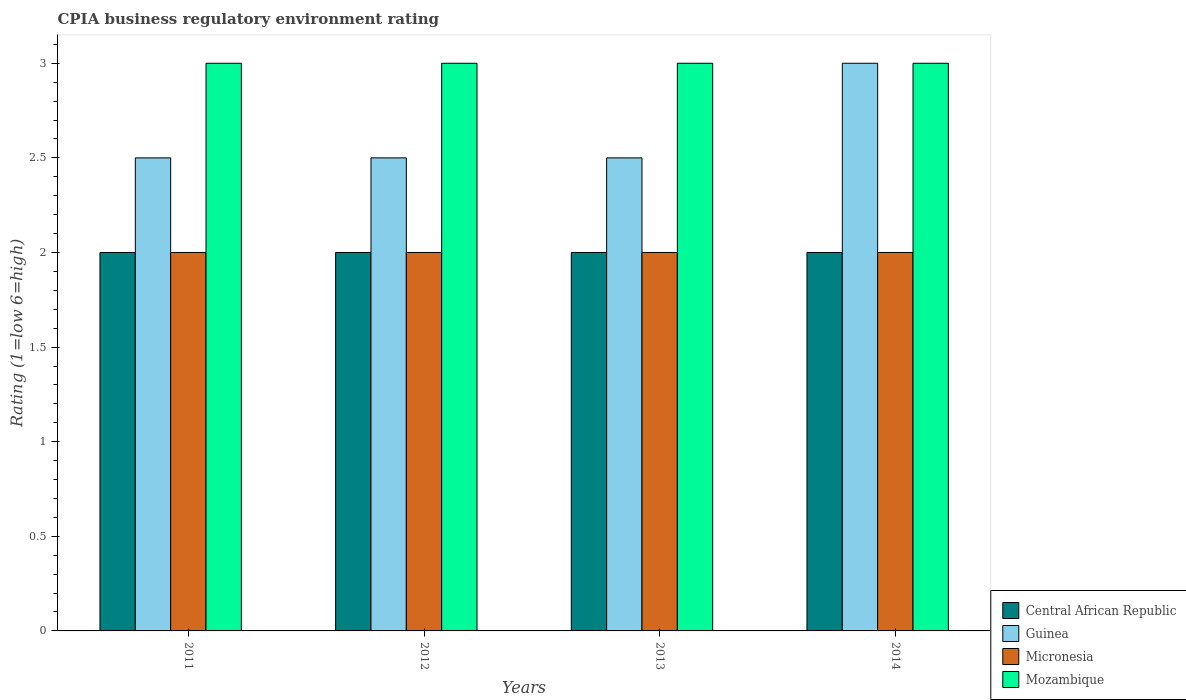How many different coloured bars are there?
Offer a terse response. 4. Are the number of bars on each tick of the X-axis equal?
Provide a short and direct response. Yes. In how many cases, is the number of bars for a given year not equal to the number of legend labels?
Your answer should be very brief. 0. What is the CPIA rating in Guinea in 2011?
Your answer should be compact. 2.5. Across all years, what is the maximum CPIA rating in Central African Republic?
Your answer should be very brief. 2. In which year was the CPIA rating in Micronesia maximum?
Make the answer very short. 2011. In which year was the CPIA rating in Guinea minimum?
Your response must be concise. 2011. What is the difference between the CPIA rating in Guinea in 2012 and that in 2013?
Provide a short and direct response. 0. What is the difference between the CPIA rating in Mozambique in 2012 and the CPIA rating in Micronesia in 2013?
Keep it short and to the point. 1. What is the average CPIA rating in Guinea per year?
Keep it short and to the point. 2.62. In the year 2014, what is the difference between the CPIA rating in Central African Republic and CPIA rating in Mozambique?
Give a very brief answer. -1. What is the ratio of the CPIA rating in Guinea in 2013 to that in 2014?
Your answer should be very brief. 0.83. What is the difference between the highest and the second highest CPIA rating in Guinea?
Offer a terse response. 0.5. Is the sum of the CPIA rating in Mozambique in 2011 and 2012 greater than the maximum CPIA rating in Central African Republic across all years?
Your response must be concise. Yes. What does the 4th bar from the left in 2011 represents?
Make the answer very short. Mozambique. What does the 1st bar from the right in 2013 represents?
Keep it short and to the point. Mozambique. Is it the case that in every year, the sum of the CPIA rating in Guinea and CPIA rating in Micronesia is greater than the CPIA rating in Central African Republic?
Your answer should be very brief. Yes. How many years are there in the graph?
Offer a very short reply. 4. What is the difference between two consecutive major ticks on the Y-axis?
Your answer should be very brief. 0.5. Are the values on the major ticks of Y-axis written in scientific E-notation?
Offer a terse response. No. Does the graph contain any zero values?
Ensure brevity in your answer.  No. Does the graph contain grids?
Your answer should be very brief. No. How many legend labels are there?
Offer a very short reply. 4. What is the title of the graph?
Provide a succinct answer. CPIA business regulatory environment rating. Does "Uganda" appear as one of the legend labels in the graph?
Make the answer very short. No. What is the label or title of the Y-axis?
Offer a terse response. Rating (1=low 6=high). What is the Rating (1=low 6=high) of Central African Republic in 2011?
Your response must be concise. 2. What is the Rating (1=low 6=high) of Mozambique in 2011?
Give a very brief answer. 3. What is the Rating (1=low 6=high) of Central African Republic in 2012?
Offer a terse response. 2. What is the Rating (1=low 6=high) in Central African Republic in 2013?
Offer a terse response. 2. What is the Rating (1=low 6=high) of Guinea in 2013?
Make the answer very short. 2.5. What is the Rating (1=low 6=high) of Guinea in 2014?
Provide a short and direct response. 3. What is the Rating (1=low 6=high) of Mozambique in 2014?
Offer a terse response. 3. Across all years, what is the maximum Rating (1=low 6=high) in Mozambique?
Give a very brief answer. 3. Across all years, what is the minimum Rating (1=low 6=high) of Guinea?
Your response must be concise. 2.5. Across all years, what is the minimum Rating (1=low 6=high) in Micronesia?
Your answer should be compact. 2. What is the difference between the Rating (1=low 6=high) in Central African Republic in 2011 and that in 2012?
Provide a succinct answer. 0. What is the difference between the Rating (1=low 6=high) of Guinea in 2011 and that in 2013?
Make the answer very short. 0. What is the difference between the Rating (1=low 6=high) in Mozambique in 2011 and that in 2013?
Offer a very short reply. 0. What is the difference between the Rating (1=low 6=high) of Mozambique in 2011 and that in 2014?
Make the answer very short. 0. What is the difference between the Rating (1=low 6=high) of Central African Republic in 2012 and that in 2013?
Give a very brief answer. 0. What is the difference between the Rating (1=low 6=high) of Guinea in 2012 and that in 2013?
Offer a terse response. 0. What is the difference between the Rating (1=low 6=high) in Micronesia in 2012 and that in 2013?
Your answer should be very brief. 0. What is the difference between the Rating (1=low 6=high) of Central African Republic in 2013 and that in 2014?
Your response must be concise. 0. What is the difference between the Rating (1=low 6=high) in Micronesia in 2013 and that in 2014?
Provide a succinct answer. 0. What is the difference between the Rating (1=low 6=high) in Mozambique in 2013 and that in 2014?
Make the answer very short. 0. What is the difference between the Rating (1=low 6=high) in Central African Republic in 2011 and the Rating (1=low 6=high) in Mozambique in 2012?
Offer a terse response. -1. What is the difference between the Rating (1=low 6=high) of Guinea in 2011 and the Rating (1=low 6=high) of Micronesia in 2012?
Provide a succinct answer. 0.5. What is the difference between the Rating (1=low 6=high) of Guinea in 2011 and the Rating (1=low 6=high) of Mozambique in 2012?
Provide a succinct answer. -0.5. What is the difference between the Rating (1=low 6=high) of Central African Republic in 2011 and the Rating (1=low 6=high) of Micronesia in 2013?
Provide a succinct answer. 0. What is the difference between the Rating (1=low 6=high) in Central African Republic in 2011 and the Rating (1=low 6=high) in Mozambique in 2013?
Your answer should be very brief. -1. What is the difference between the Rating (1=low 6=high) of Guinea in 2011 and the Rating (1=low 6=high) of Micronesia in 2013?
Offer a terse response. 0.5. What is the difference between the Rating (1=low 6=high) of Guinea in 2011 and the Rating (1=low 6=high) of Mozambique in 2013?
Make the answer very short. -0.5. What is the difference between the Rating (1=low 6=high) of Central African Republic in 2011 and the Rating (1=low 6=high) of Micronesia in 2014?
Give a very brief answer. 0. What is the difference between the Rating (1=low 6=high) of Central African Republic in 2011 and the Rating (1=low 6=high) of Mozambique in 2014?
Your answer should be compact. -1. What is the difference between the Rating (1=low 6=high) in Guinea in 2011 and the Rating (1=low 6=high) in Micronesia in 2014?
Give a very brief answer. 0.5. What is the difference between the Rating (1=low 6=high) in Central African Republic in 2012 and the Rating (1=low 6=high) in Micronesia in 2013?
Your answer should be very brief. 0. What is the difference between the Rating (1=low 6=high) in Central African Republic in 2012 and the Rating (1=low 6=high) in Mozambique in 2013?
Give a very brief answer. -1. What is the difference between the Rating (1=low 6=high) in Guinea in 2012 and the Rating (1=low 6=high) in Mozambique in 2013?
Ensure brevity in your answer.  -0.5. What is the difference between the Rating (1=low 6=high) in Central African Republic in 2012 and the Rating (1=low 6=high) in Micronesia in 2014?
Provide a succinct answer. 0. What is the difference between the Rating (1=low 6=high) in Micronesia in 2012 and the Rating (1=low 6=high) in Mozambique in 2014?
Keep it short and to the point. -1. What is the difference between the Rating (1=low 6=high) in Central African Republic in 2013 and the Rating (1=low 6=high) in Micronesia in 2014?
Make the answer very short. 0. What is the difference between the Rating (1=low 6=high) in Central African Republic in 2013 and the Rating (1=low 6=high) in Mozambique in 2014?
Make the answer very short. -1. What is the difference between the Rating (1=low 6=high) of Guinea in 2013 and the Rating (1=low 6=high) of Micronesia in 2014?
Give a very brief answer. 0.5. What is the difference between the Rating (1=low 6=high) of Guinea in 2013 and the Rating (1=low 6=high) of Mozambique in 2014?
Make the answer very short. -0.5. What is the average Rating (1=low 6=high) in Guinea per year?
Your answer should be very brief. 2.62. What is the average Rating (1=low 6=high) of Micronesia per year?
Your answer should be very brief. 2. What is the average Rating (1=low 6=high) of Mozambique per year?
Make the answer very short. 3. In the year 2011, what is the difference between the Rating (1=low 6=high) of Guinea and Rating (1=low 6=high) of Micronesia?
Offer a very short reply. 0.5. In the year 2012, what is the difference between the Rating (1=low 6=high) in Central African Republic and Rating (1=low 6=high) in Micronesia?
Your response must be concise. 0. In the year 2012, what is the difference between the Rating (1=low 6=high) of Central African Republic and Rating (1=low 6=high) of Mozambique?
Give a very brief answer. -1. In the year 2012, what is the difference between the Rating (1=low 6=high) of Guinea and Rating (1=low 6=high) of Micronesia?
Offer a terse response. 0.5. In the year 2013, what is the difference between the Rating (1=low 6=high) in Central African Republic and Rating (1=low 6=high) in Mozambique?
Offer a very short reply. -1. In the year 2014, what is the difference between the Rating (1=low 6=high) in Central African Republic and Rating (1=low 6=high) in Guinea?
Your answer should be very brief. -1. In the year 2014, what is the difference between the Rating (1=low 6=high) of Central African Republic and Rating (1=low 6=high) of Micronesia?
Keep it short and to the point. 0. In the year 2014, what is the difference between the Rating (1=low 6=high) in Central African Republic and Rating (1=low 6=high) in Mozambique?
Your response must be concise. -1. In the year 2014, what is the difference between the Rating (1=low 6=high) in Guinea and Rating (1=low 6=high) in Micronesia?
Keep it short and to the point. 1. In the year 2014, what is the difference between the Rating (1=low 6=high) of Guinea and Rating (1=low 6=high) of Mozambique?
Make the answer very short. 0. What is the ratio of the Rating (1=low 6=high) in Central African Republic in 2011 to that in 2012?
Ensure brevity in your answer.  1. What is the ratio of the Rating (1=low 6=high) of Guinea in 2011 to that in 2012?
Make the answer very short. 1. What is the ratio of the Rating (1=low 6=high) of Micronesia in 2011 to that in 2012?
Ensure brevity in your answer.  1. What is the ratio of the Rating (1=low 6=high) of Central African Republic in 2011 to that in 2013?
Provide a short and direct response. 1. What is the ratio of the Rating (1=low 6=high) in Guinea in 2011 to that in 2013?
Offer a terse response. 1. What is the ratio of the Rating (1=low 6=high) in Mozambique in 2011 to that in 2013?
Make the answer very short. 1. What is the ratio of the Rating (1=low 6=high) of Central African Republic in 2011 to that in 2014?
Your answer should be very brief. 1. What is the ratio of the Rating (1=low 6=high) of Guinea in 2011 to that in 2014?
Give a very brief answer. 0.83. What is the ratio of the Rating (1=low 6=high) in Guinea in 2012 to that in 2013?
Ensure brevity in your answer.  1. What is the ratio of the Rating (1=low 6=high) of Mozambique in 2012 to that in 2013?
Give a very brief answer. 1. What is the ratio of the Rating (1=low 6=high) of Central African Republic in 2012 to that in 2014?
Your answer should be compact. 1. What is the ratio of the Rating (1=low 6=high) of Guinea in 2012 to that in 2014?
Provide a succinct answer. 0.83. What is the ratio of the Rating (1=low 6=high) in Micronesia in 2012 to that in 2014?
Ensure brevity in your answer.  1. What is the ratio of the Rating (1=low 6=high) of Mozambique in 2012 to that in 2014?
Your response must be concise. 1. What is the ratio of the Rating (1=low 6=high) in Micronesia in 2013 to that in 2014?
Your answer should be compact. 1. What is the ratio of the Rating (1=low 6=high) in Mozambique in 2013 to that in 2014?
Offer a terse response. 1. What is the difference between the highest and the second highest Rating (1=low 6=high) of Central African Republic?
Keep it short and to the point. 0. What is the difference between the highest and the second highest Rating (1=low 6=high) of Guinea?
Provide a succinct answer. 0.5. What is the difference between the highest and the second highest Rating (1=low 6=high) in Micronesia?
Give a very brief answer. 0. What is the difference between the highest and the second highest Rating (1=low 6=high) in Mozambique?
Make the answer very short. 0. What is the difference between the highest and the lowest Rating (1=low 6=high) in Central African Republic?
Provide a succinct answer. 0. What is the difference between the highest and the lowest Rating (1=low 6=high) of Micronesia?
Give a very brief answer. 0. What is the difference between the highest and the lowest Rating (1=low 6=high) of Mozambique?
Ensure brevity in your answer.  0. 